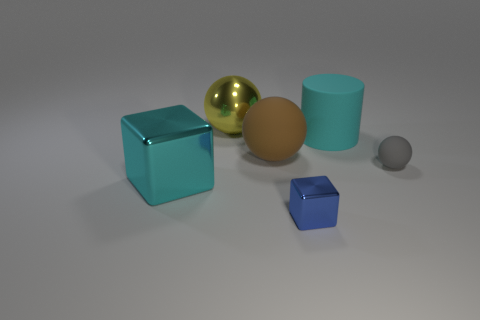Add 1 tiny cubes. How many objects exist? 7 Subtract all cylinders. How many objects are left? 5 Add 1 large brown rubber spheres. How many large brown rubber spheres are left? 2 Add 5 cyan metal things. How many cyan metal things exist? 6 Subtract 1 brown spheres. How many objects are left? 5 Subtract all metal cubes. Subtract all large purple shiny cylinders. How many objects are left? 4 